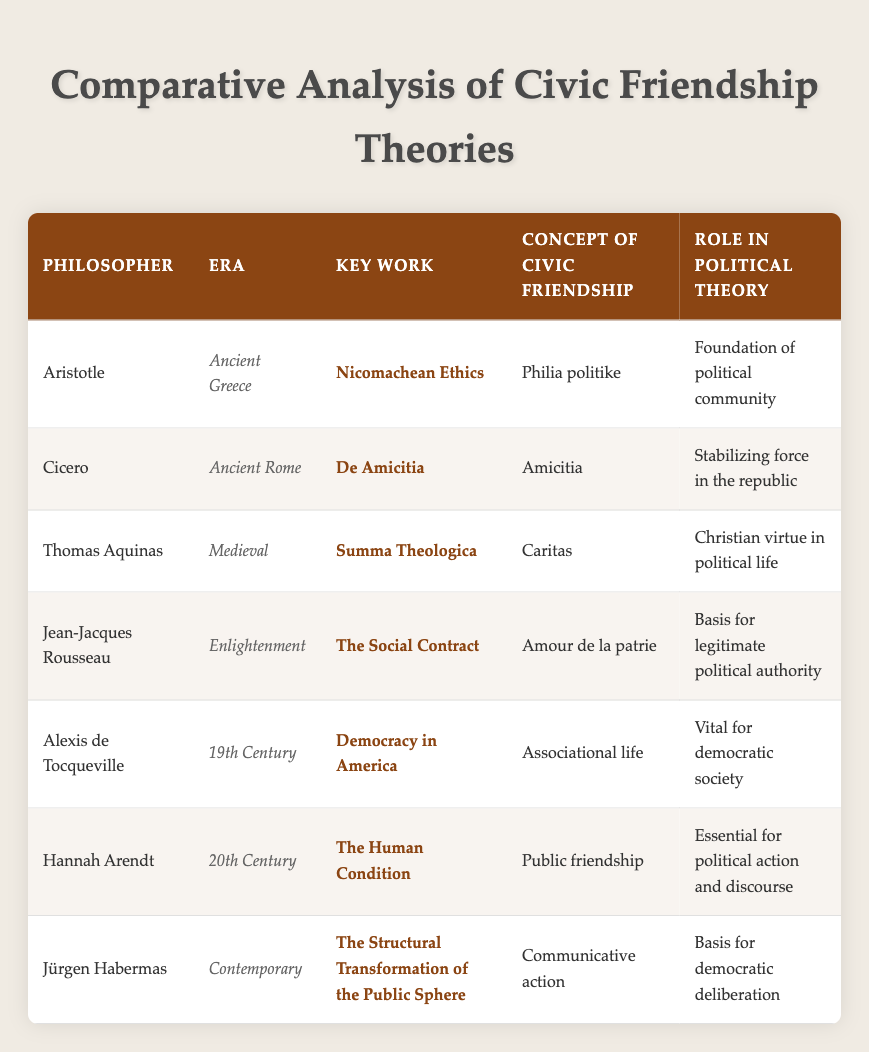What is the concept of civic friendship according to Aristotle? Aristotle's concept of civic friendship is described as "Philia politike," which emphasizes the importance of mutual goodwill and connection among citizens in a political community. This is directly sourced from the provided table under the column for Aristotle.
Answer: Philia politike Which philosopher's key work is "The Social Contract"? The table specifies under the "Key Work" column that Jean-Jacques Rousseau's significant work is "The Social Contract." This can be answered directly by looking at the relevant row.
Answer: Jean-Jacques Rousseau Is "Caritas" associated with the role of Christian virtue in political life? The table states that Thomas Aquinas' concept of civic friendship is "Caritas," which is linked to providing a foundation for Christian virtue in political life. This matches the conditions of the question, confirming its truth.
Answer: Yes Which era does Hannah Arendt belong to, and what is her role in political theory? According to the table, Hannah Arendt is from the "20th Century" era, and her role in political theory is described as "Essential for political action and discourse." Both pieces of information can be found in her respective row in the table.
Answer: 20th Century; Essential for political action and discourse What is the difference in the concept of civic friendship between Cicero and Alexis de Tocqueville? Cicero’s concept of civic friendship is "Amicitia," which he views as a stabilizing force in the republic. In contrast, Tocqueville describes it as "Associational life," emphasizing its vitality for a democratic society. This comparison involves extracting concepts from both philosophers’ entries in the table to evaluate the differences.
Answer: Amicitia vs. Associational life What role does Jürgen Habermas attribute to communicative action? The table indicates that Jürgen Habermas sees communicative action as the "Basis for democratic deliberation." This is a direct retrieval from his respective row in the table.
Answer: Basis for democratic deliberation Which philosopher emphasizes friendship's essential role in political action? The table shows that Hannah Arendt emphasizes "Public friendship" as essential for political action and discourse. This relates directly to her entry in the table.
Answer: Hannah Arendt How many philosophers discussed the role of civic friendship in a democratic context? To assess this, we identify entries associated with democracy: Alexis de Tocqueville (19th Century) and Jürgen Habermas (Contemporary). Thus, there are two philosophers who specifically address democratic contexts in relation to civic friendship.
Answer: 2 